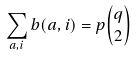Convert formula to latex. <formula><loc_0><loc_0><loc_500><loc_500>\sum _ { a , i } b ( a , i ) = p \binom { q } { 2 }</formula> 